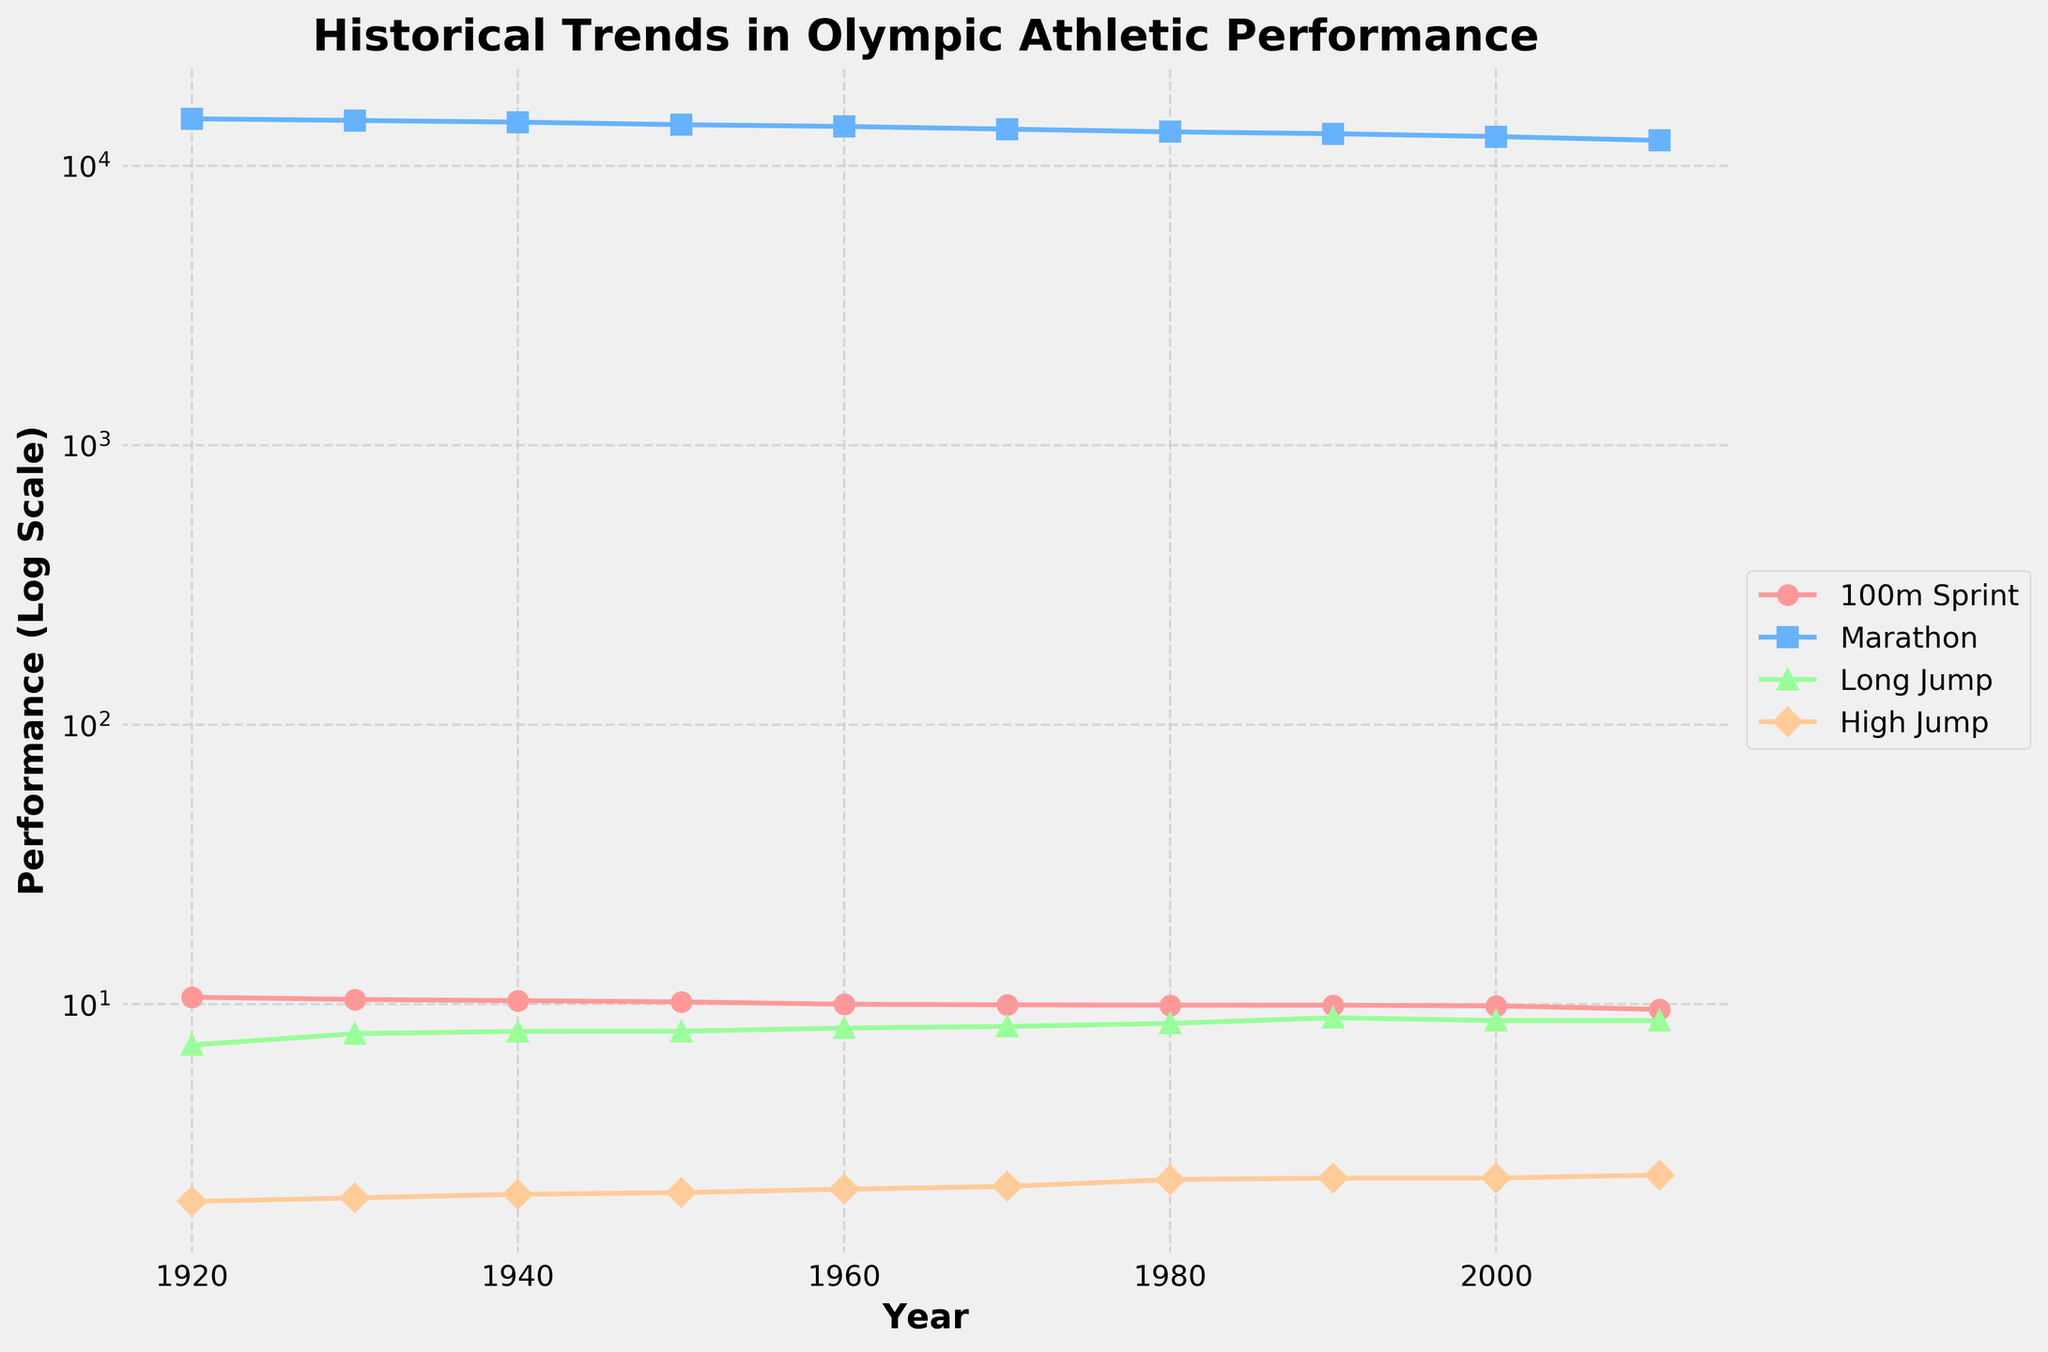How many events are displayed in the plot? The plot labels indicate each line represents a different event. Counting the lines and their legend, we find: "100m Sprint," "Marathon," "Long Jump," and "High Jump."
Answer: Four Which event shows the most significant performance improvement from 1920 to 2010? By looking at the lines' steepness on the log scale, the "100m Sprint" line takes the sharpest decline, showing the greatest improvement.
Answer: 100m Sprint What is the performance value for the high jump event in 2010? The plot's legend shows each event, and by following the "High Jump" line until 2010, we see the performance value at that point.
Answer: 2.45 Between which decades did the marathon event show the most improvement? The line for the "Marathon" event shows the steepest decline between 2000 and 2010, indicating the most improvement in performance.
Answer: 2000 to 2010 Which event had no performance improvement between 2000 and 2010? The line representing the "Long Jump" event remains flat between the years 2000 and 2010, indicating no performance improvement.
Answer: Long Jump Which event has the highest performance value in 1940? By referring to the lines and their values at the year 1940, the "Marathon" event has the largest numerical value.
Answer: Marathon What is the trend of the 100m sprint event performance over the decades shown? The "100m Sprint" line shows a continuous downward trend, indicating a consistent improvement in performance over time.
Answer: Continuous improvement For the long jump event, what is the average performance value over all shown decades? The performance values for the "Long Jump" event (7.15, 7.85, 8.00, 8.01, 8.22, 8.33, 8.54, 8.95, 8.74, 8.74) are averaged: (7.15 + 7.85 + 8.00 + 8.01 + 8.22 + 8.33 + 8.54 + 8.95 + 8.74 + 8.74) / 10 ≈ 8.353.
Answer: 8.35 Which event's performance in 2010 decreased compared to 2000? By comparing the 2000 and 2010 values on the "Long Jump" event’s line, we see a slight decrease in performance (8.74 in 2000 to 8.74 in 2010).
Answer: Long Jump 